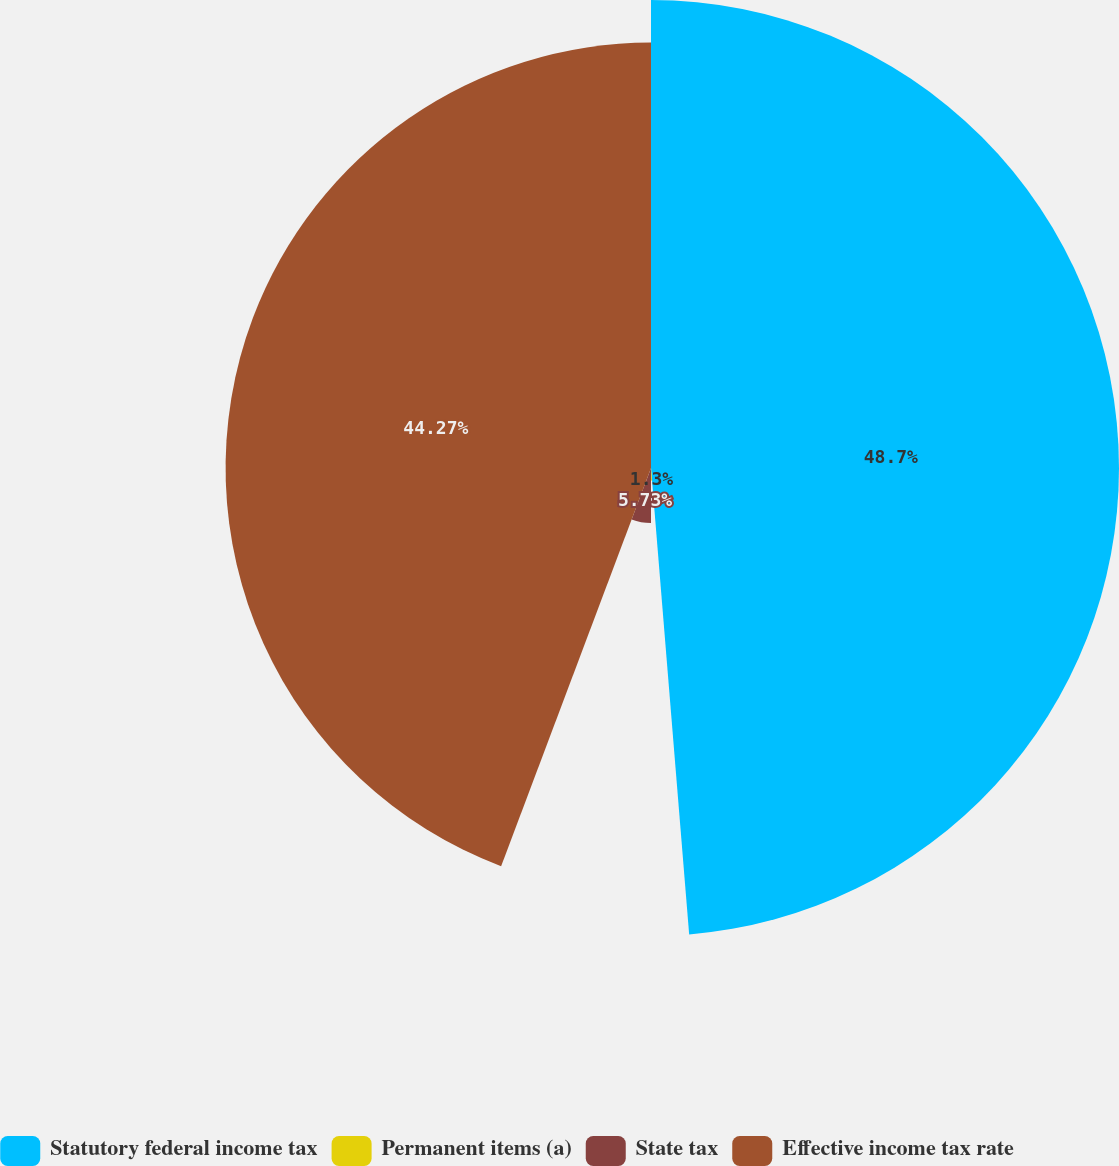<chart> <loc_0><loc_0><loc_500><loc_500><pie_chart><fcel>Statutory federal income tax<fcel>Permanent items (a)<fcel>State tax<fcel>Effective income tax rate<nl><fcel>48.7%<fcel>1.3%<fcel>5.73%<fcel>44.27%<nl></chart> 